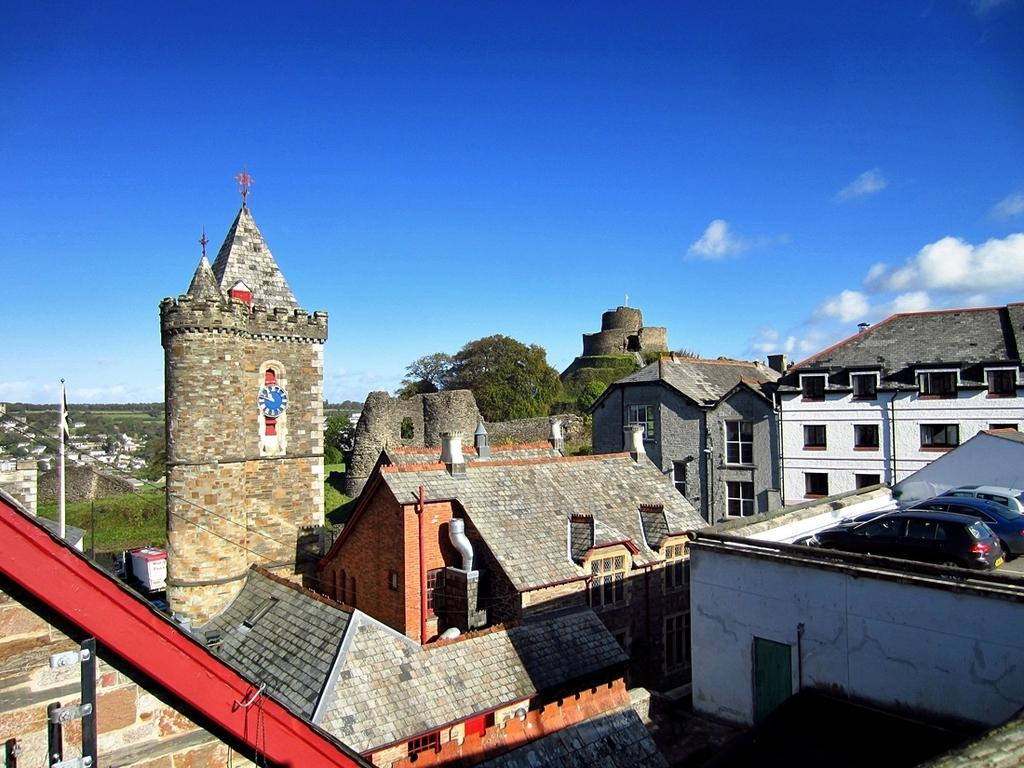What type of structures are present in the image? There are houses in the image. What type of vegetation can be seen in the image? There are trees and grass in the image. What is visible in the background of the image? The sky is visible in the background of the image. Is there any blood visible on the grass in the image? No, there is no blood visible on the grass in the image. Can you see a hen walking around in the image? No, there is no hen present in the image. 